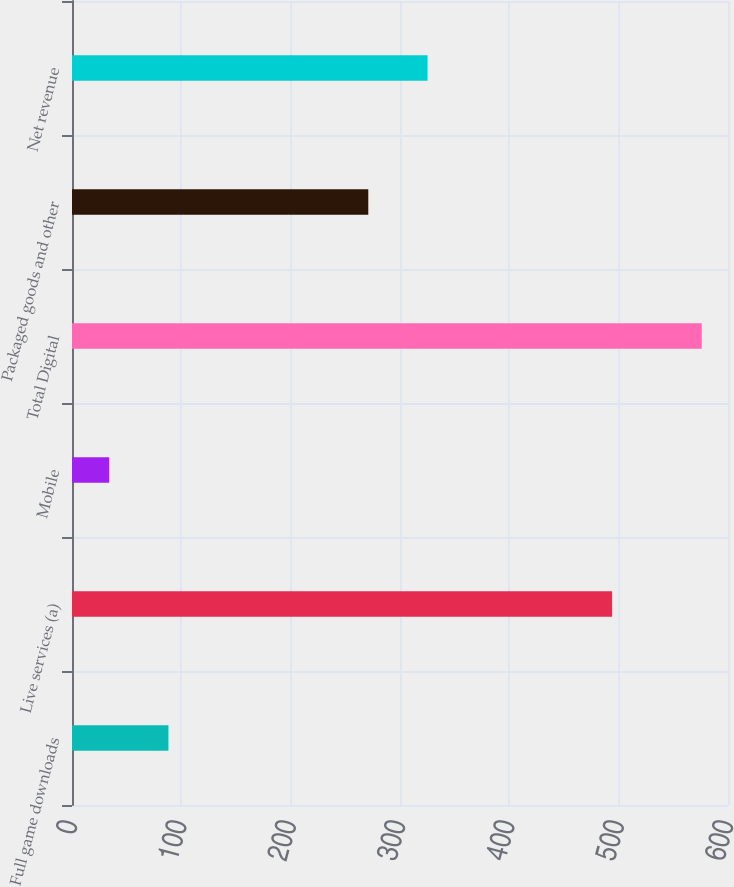Convert chart to OTSL. <chart><loc_0><loc_0><loc_500><loc_500><bar_chart><fcel>Full game downloads<fcel>Live services (a)<fcel>Mobile<fcel>Total Digital<fcel>Packaged goods and other<fcel>Net revenue<nl><fcel>88.2<fcel>494<fcel>34<fcel>576<fcel>271<fcel>325.2<nl></chart> 